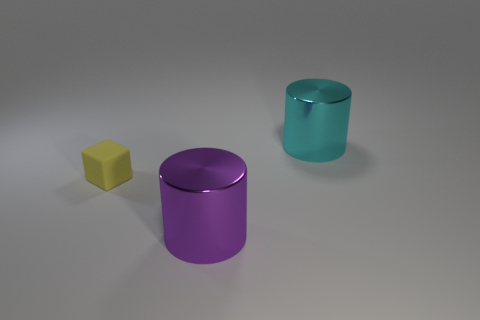Add 3 big cyan objects. How many objects exist? 6 Subtract all cylinders. How many objects are left? 1 Add 2 big cyan metallic cylinders. How many big cyan metallic cylinders are left? 3 Add 1 big purple metal things. How many big purple metal things exist? 2 Subtract 0 brown spheres. How many objects are left? 3 Subtract all purple shiny objects. Subtract all small blocks. How many objects are left? 1 